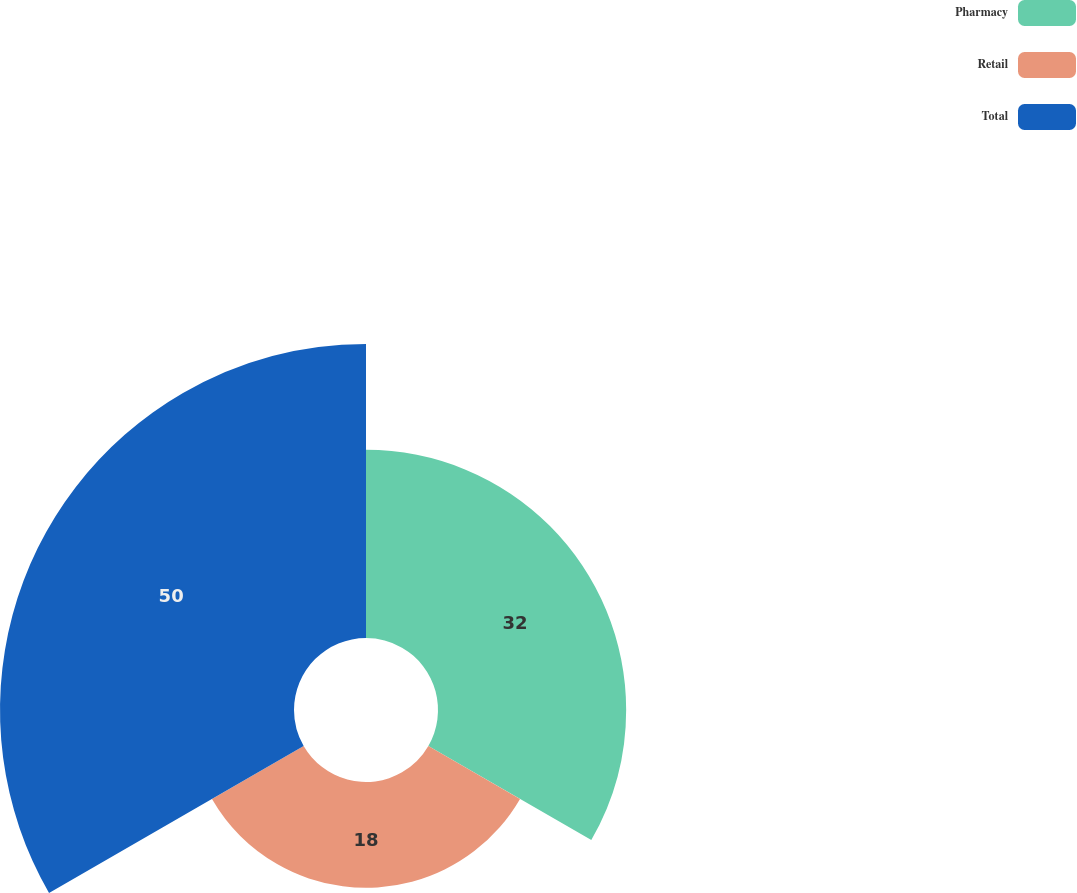<chart> <loc_0><loc_0><loc_500><loc_500><pie_chart><fcel>Pharmacy<fcel>Retail<fcel>Total<nl><fcel>32.0%<fcel>18.0%<fcel>50.0%<nl></chart> 